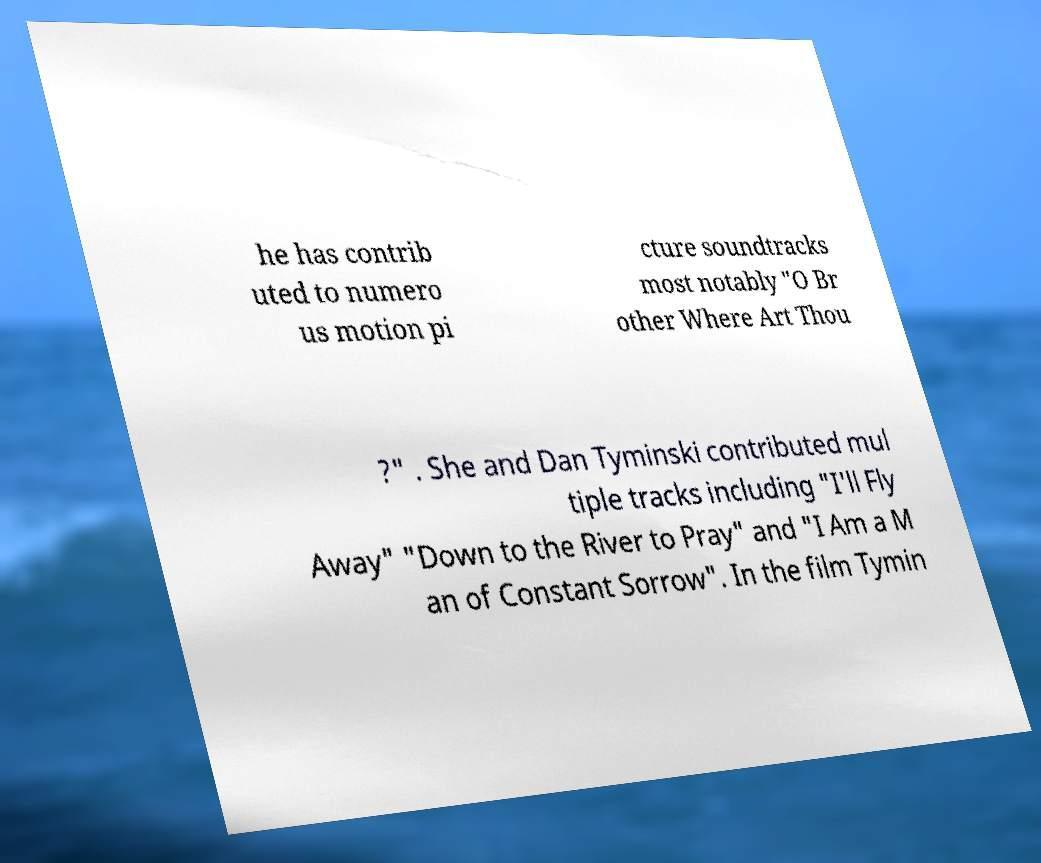What messages or text are displayed in this image? I need them in a readable, typed format. he has contrib uted to numero us motion pi cture soundtracks most notably "O Br other Where Art Thou ?" . She and Dan Tyminski contributed mul tiple tracks including "I'll Fly Away" "Down to the River to Pray" and "I Am a M an of Constant Sorrow". In the film Tymin 